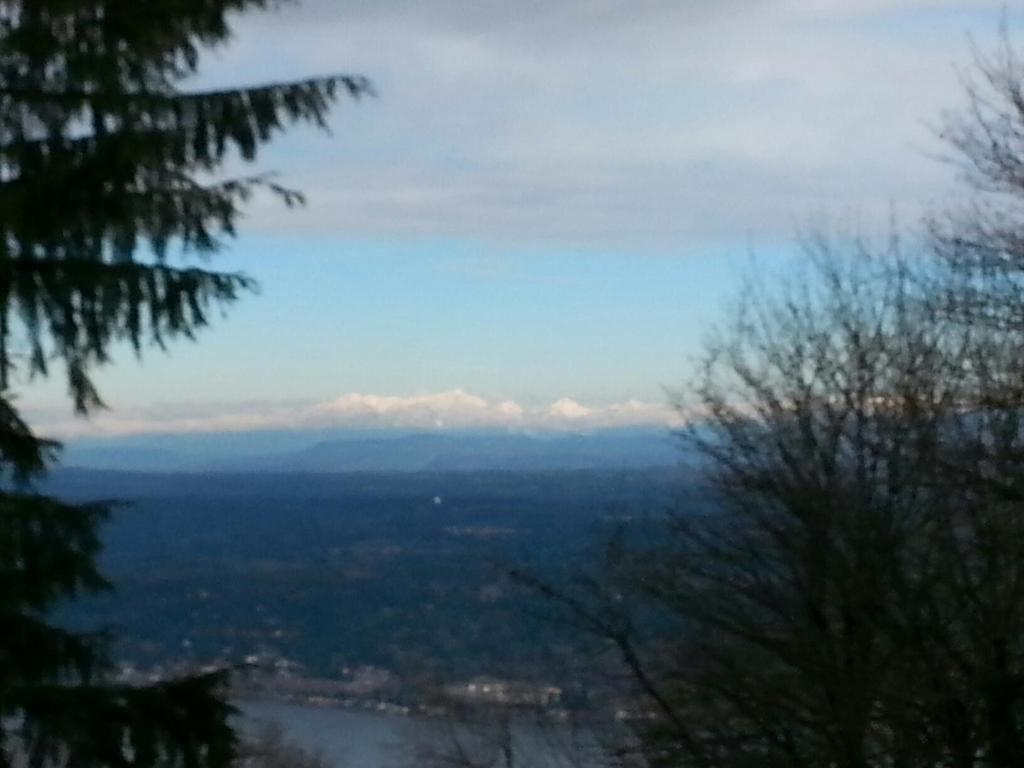What type of vegetation can be seen on both sides of the image? There are trees on either side of the image. What is the landscape like in the front of the image? The land in the front of the image is covered with plants and trees. What part of the natural environment is visible in the image? The sky is visible in the image. What can be observed in the sky? Clouds are present in the sky. What type of stamp can be seen on the tree in the image? There is no stamp present on any tree in the image. What decision is being made by the clouds in the image? The clouds in the image are not making any decisions; they are simply part of the natural environment. 